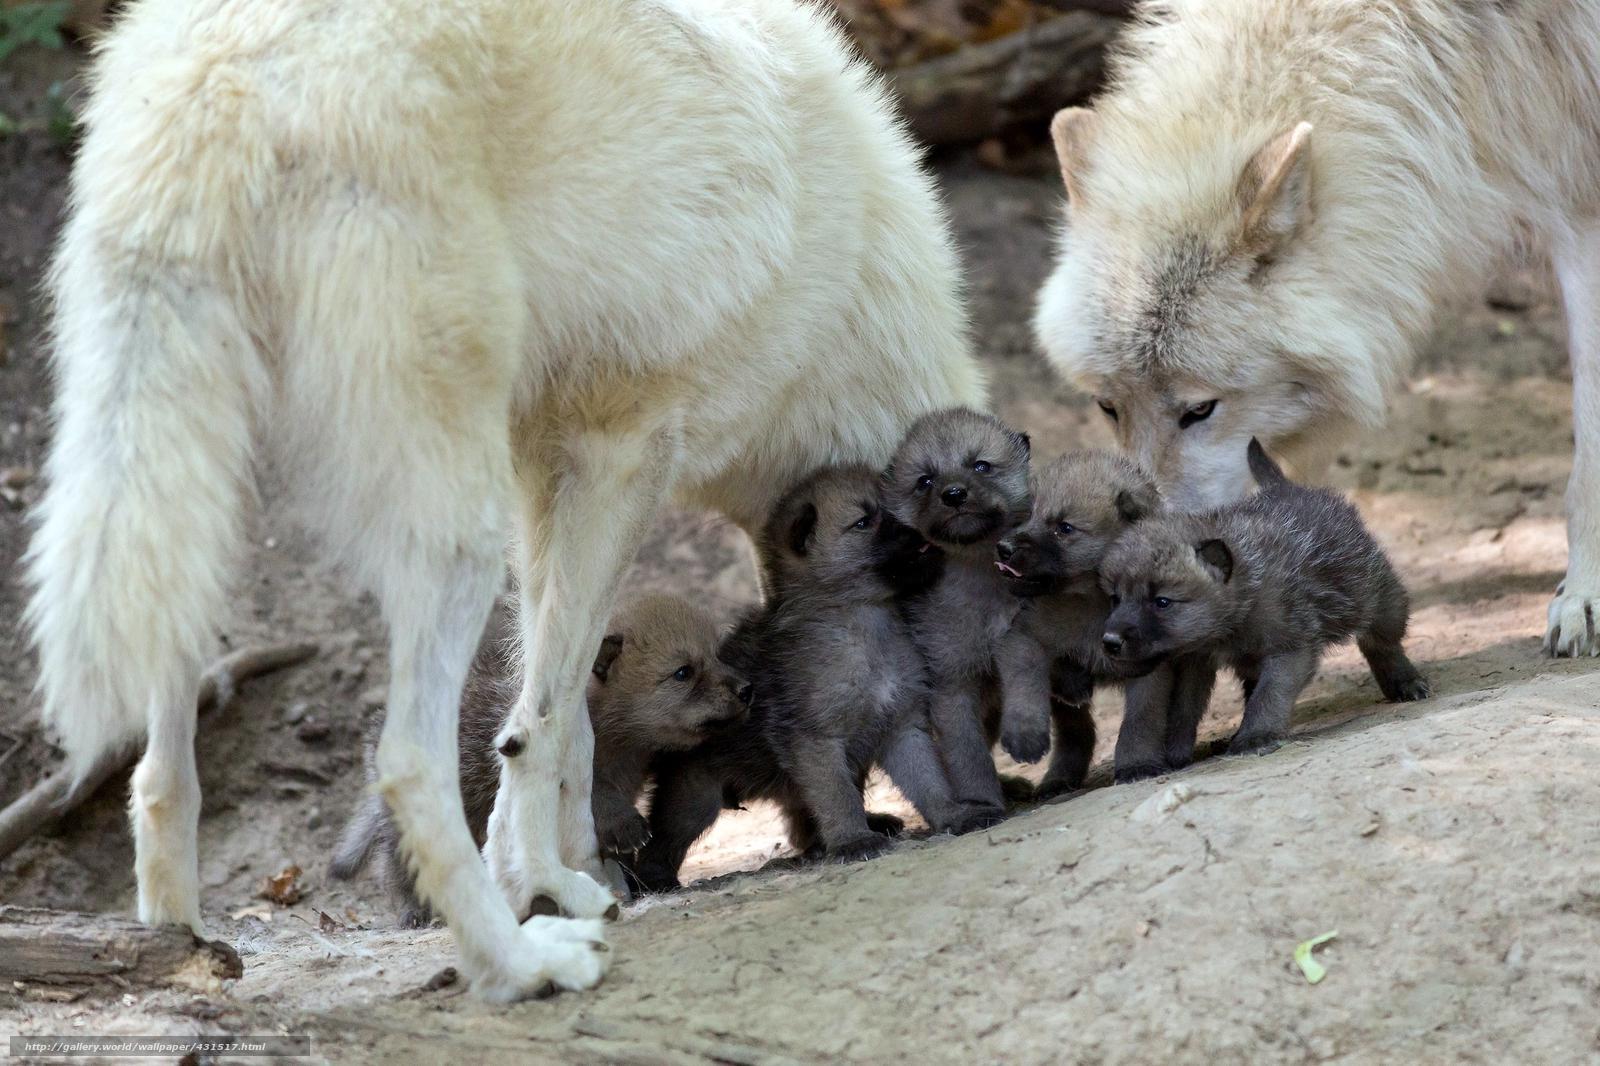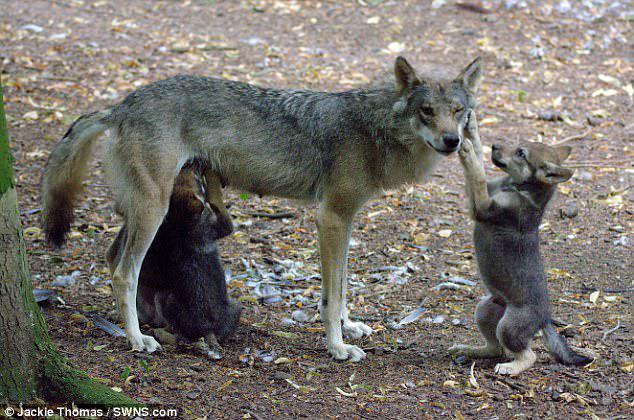The first image is the image on the left, the second image is the image on the right. Assess this claim about the two images: "One image shows no adult wolves, and the other image shows a standing adult wolf with multiple pups.". Correct or not? Answer yes or no. No. The first image is the image on the left, the second image is the image on the right. For the images shown, is this caption "Several pups are nursing in the image on the left." true? Answer yes or no. Yes. 